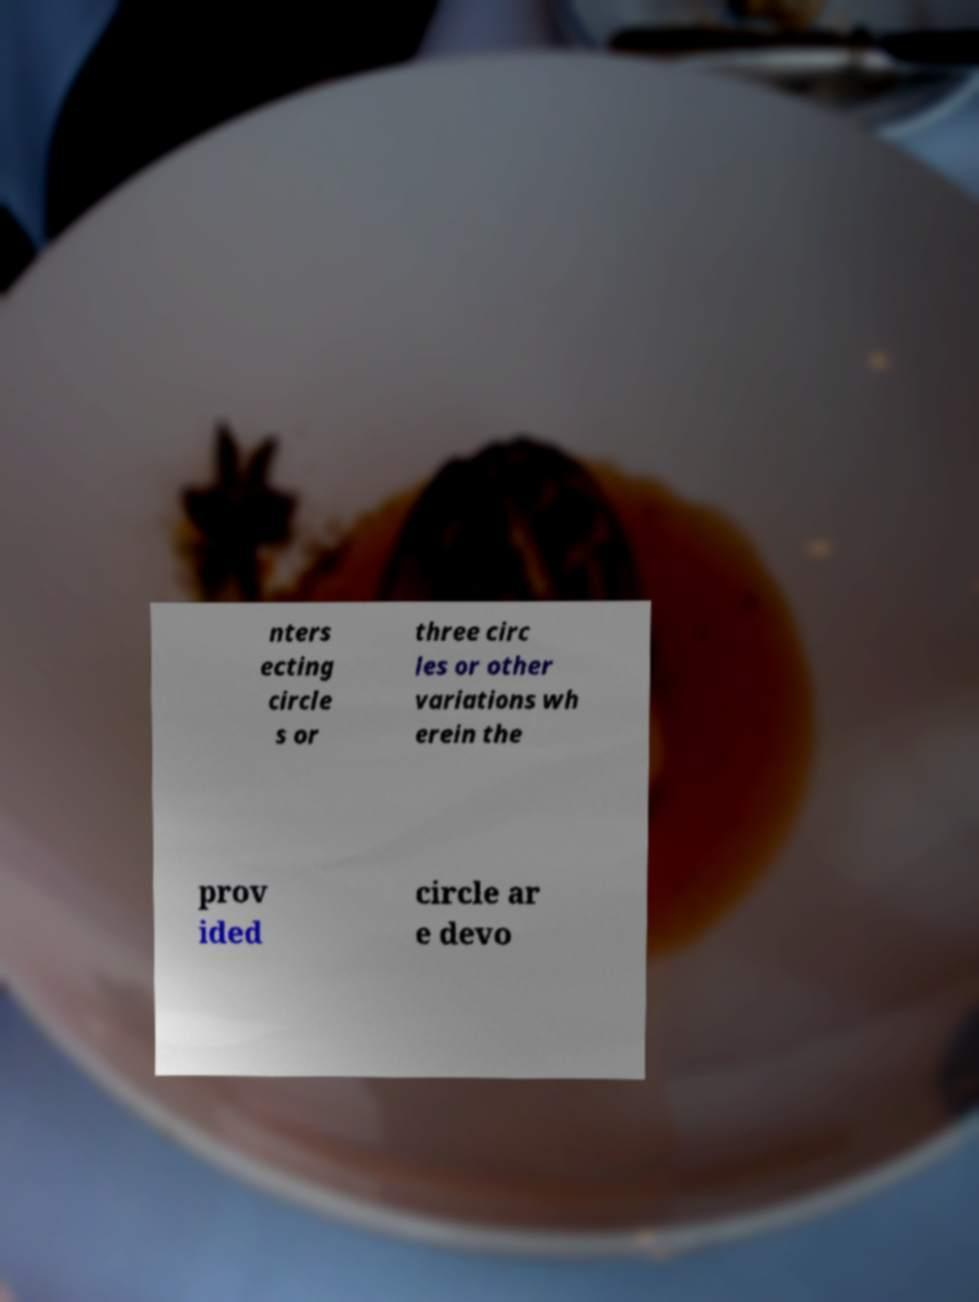Can you read and provide the text displayed in the image?This photo seems to have some interesting text. Can you extract and type it out for me? nters ecting circle s or three circ les or other variations wh erein the prov ided circle ar e devo 